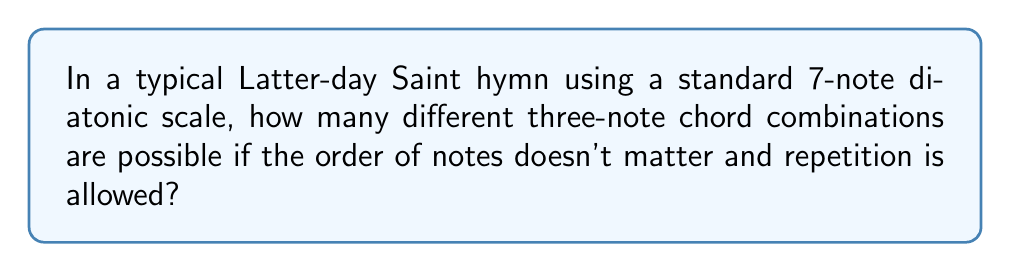What is the answer to this math problem? Let's approach this step-by-step:

1) This is a combination problem with repetition allowed. We can use the formula for combinations with repetition:

   $${n+r-1 \choose r}$$

   where $n$ is the number of items to choose from, and $r$ is the number of items being chosen.

2) In this case:
   - $n = 7$ (7 notes in a diatonic scale)
   - $r = 3$ (we're choosing 3 notes for each chord)

3) Plugging these values into our formula:

   $${7+3-1 \choose 3} = {9 \choose 3}$$

4) We can calculate this as:

   $${9 \choose 3} = \frac{9!}{3!(9-3)!} = \frac{9!}{3!6!}$$

5) Expanding this:
   
   $$\frac{9 \cdot 8 \cdot 7 \cdot 6!}{(3 \cdot 2 \cdot 1) \cdot 6!}$$

6) The 6! cancels out in the numerator and denominator:

   $$\frac{9 \cdot 8 \cdot 7}{3 \cdot 2 \cdot 1} = \frac{504}{6} = 84$$

Thus, there are 84 possible three-note chord combinations in a 7-note diatonic scale.
Answer: 84 